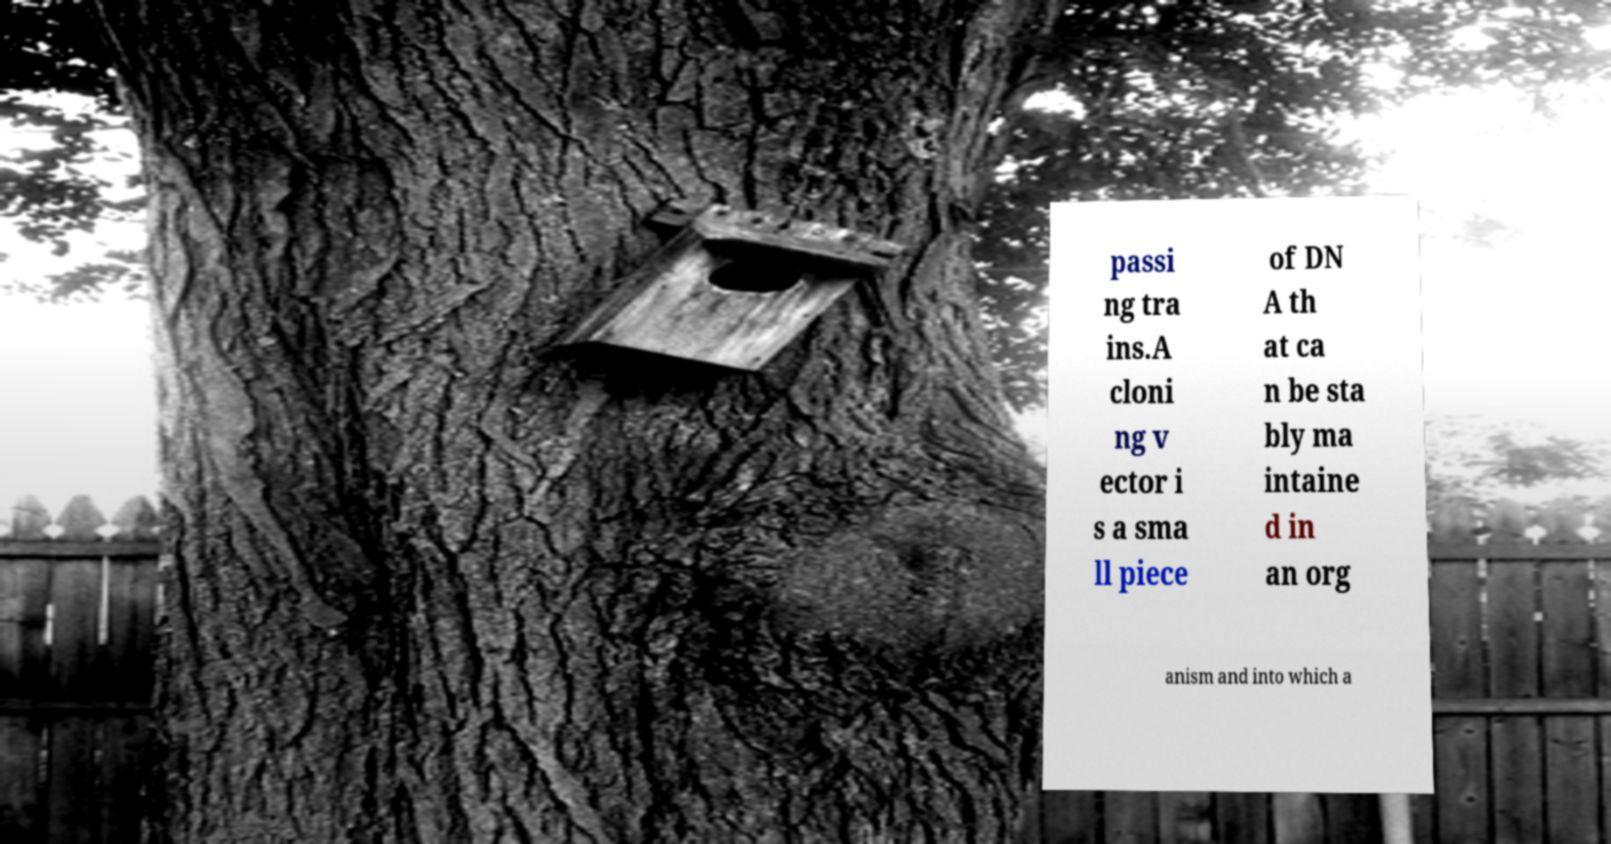For documentation purposes, I need the text within this image transcribed. Could you provide that? passi ng tra ins.A cloni ng v ector i s a sma ll piece of DN A th at ca n be sta bly ma intaine d in an org anism and into which a 